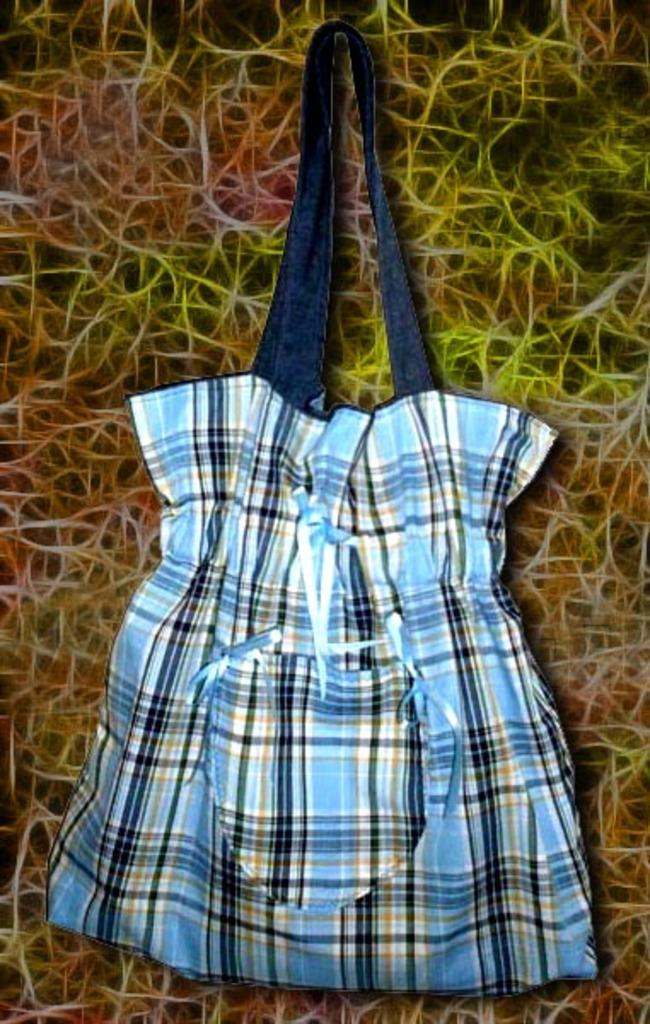What object can be seen in the image? The bag is in the image. Can you describe the colors of the bag? The bag is blue, black, and white in color. What type of ornament is hanging from the bag in the image? There is no ornament hanging from the bag in the image. Which organization is responsible for the development of the bag in the image? The provided facts do not mention any organization or development related to the bag. 